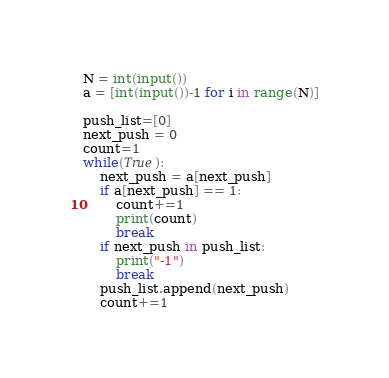Convert code to text. <code><loc_0><loc_0><loc_500><loc_500><_Python_>N = int(input())
a = [int(input())-1 for i in range(N)]

push_list=[0]
next_push = 0
count=1
while(True):
    next_push = a[next_push]
    if a[next_push] == 1:
        count+=1
        print(count)
        break
    if next_push in push_list:
        print("-1")
        break
    push_list.append(next_push)
    count+=1</code> 